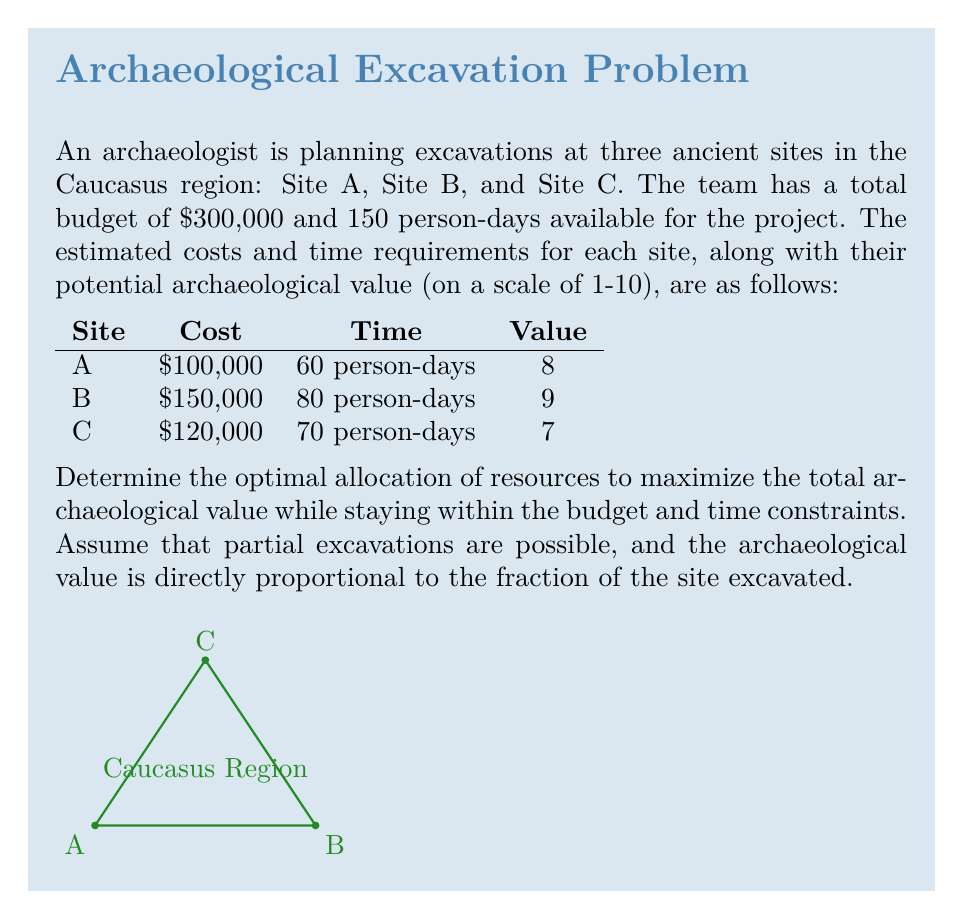Solve this math problem. To solve this problem, we'll use linear programming. Let's define our variables:

$x_A$, $x_B$, and $x_C$ represent the fraction of each site to be excavated.

1) Objective function:
Maximize $Z = 8x_A + 9x_B + 7x_C$

2) Constraints:
Budget: $100,000x_A + 150,000x_B + 120,000x_C \leq 300,000$
Time: $60x_A + 80x_B + 70x_C \leq 150$
Fractions: $0 \leq x_A, x_B, x_C \leq 1$

3) Simplify the constraints:
Budget: $x_A + 1.5x_B + 1.2x_C \leq 3$
Time: $2x_A + \frac{8}{3}x_B + \frac{7}{3}x_C \leq 5$

4) Solve using the simplex method or linear programming software.

5) The optimal solution is:
$x_A = 1$ (fully excavate Site A)
$x_B = 0.8$ (excavate 80% of Site B)
$x_C = 0.5$ (excavate 50% of Site C)

6) Verify the solution:
Budget: $100,000 + 0.8(150,000) + 0.5(120,000) = 300,000$
Time: $60 + 0.8(80) + 0.5(70) = 149$ person-days

7) Calculate the total archaeological value:
$Z = 8(1) + 9(0.8) + 7(0.5) = 15.7$
Answer: Site A: 100%, Site B: 80%, Site C: 50%; Total value: 15.7 